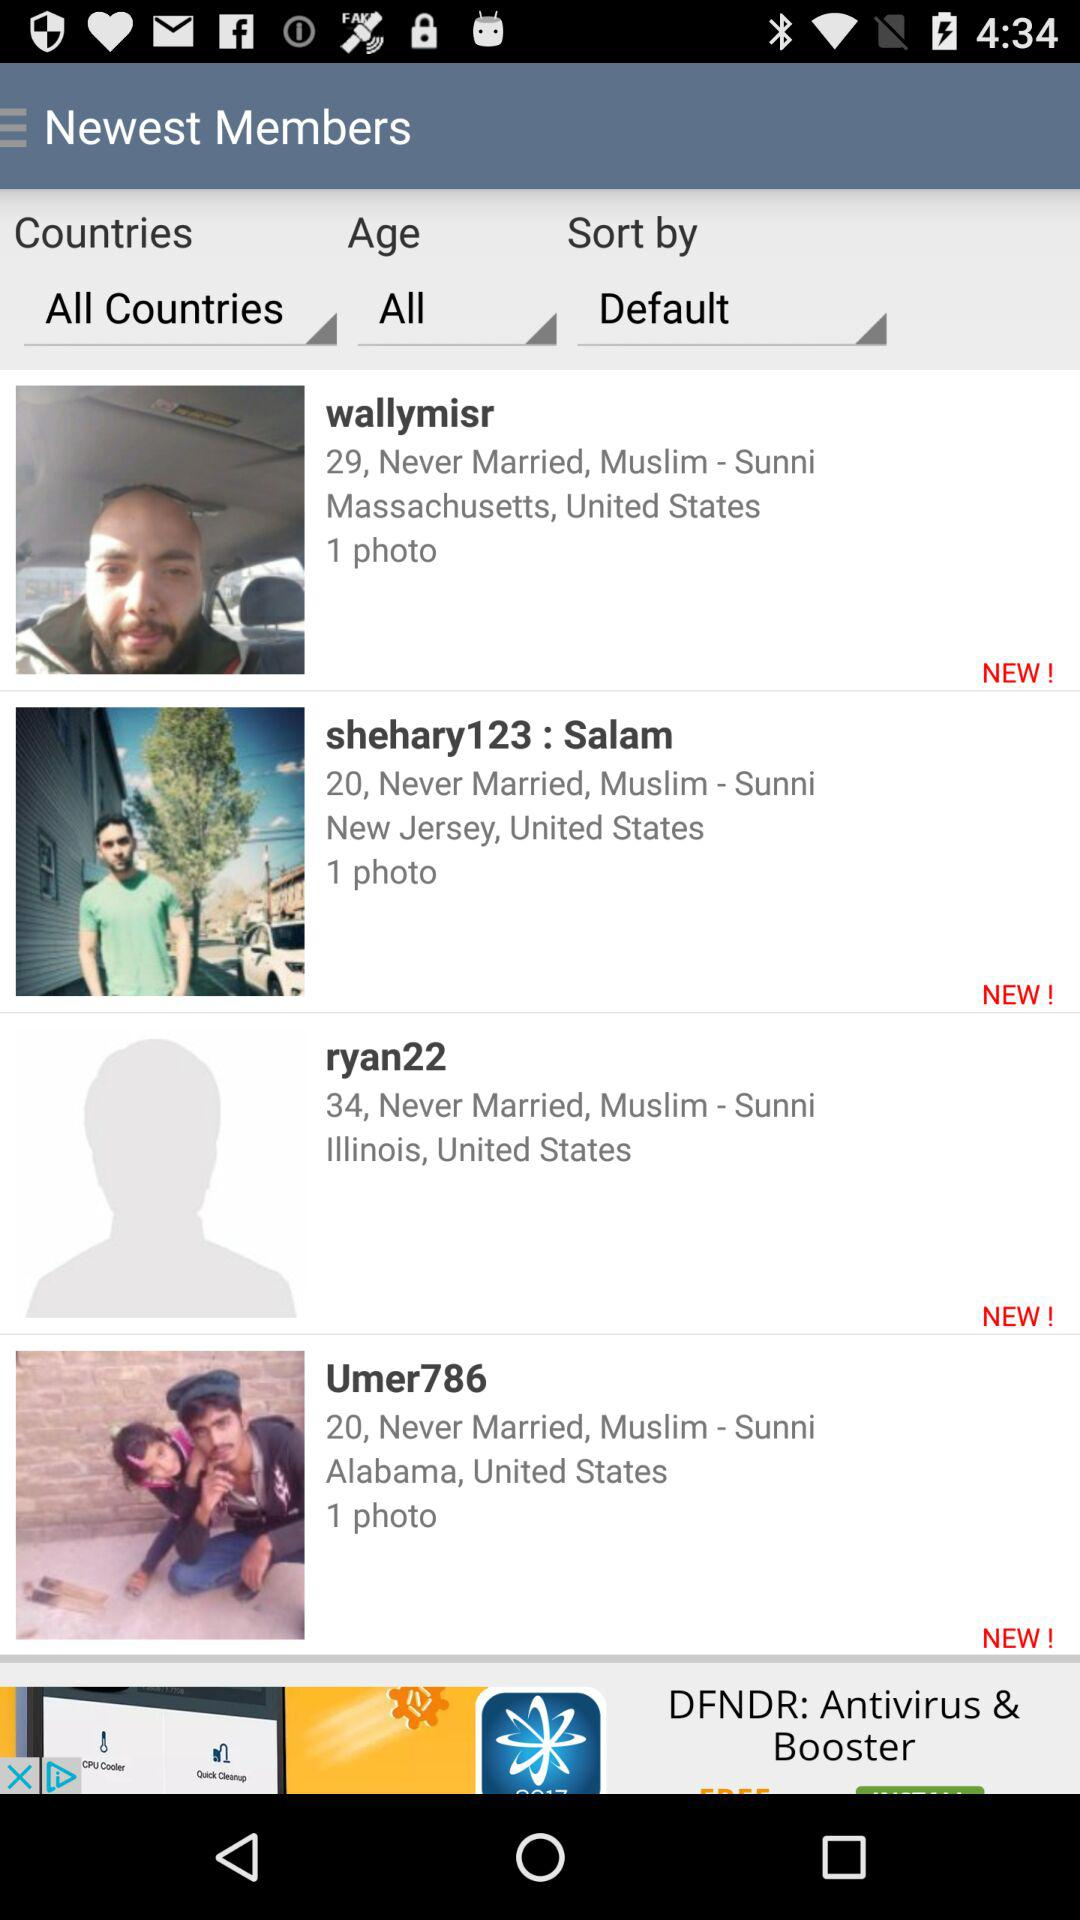Which religion does "wallymisr" follow? "wallymisr" follows the Muslim - Sunni religion. 